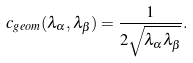Convert formula to latex. <formula><loc_0><loc_0><loc_500><loc_500>c _ { g e o m } ( \lambda _ { \alpha } , \lambda _ { \beta } ) = \frac { 1 } { 2 \sqrt { \lambda _ { \alpha } \lambda _ { \beta } } } .</formula> 